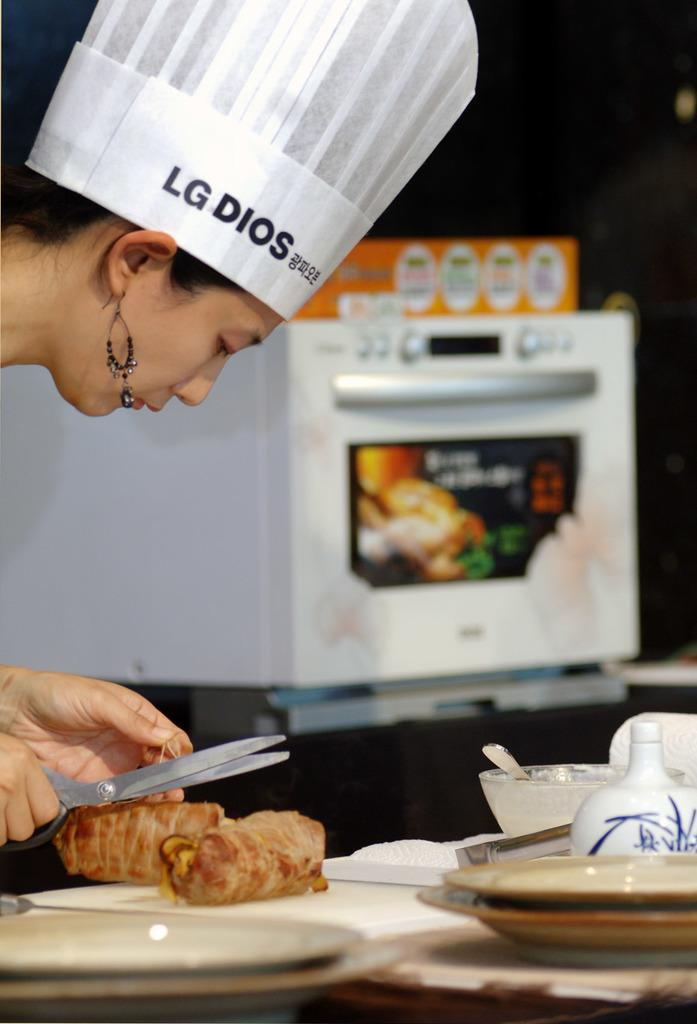Provide a one-sentence caption for the provided image. A woman preparing meat rolls wears beaded earrings and a hat saying "LG Dios". 